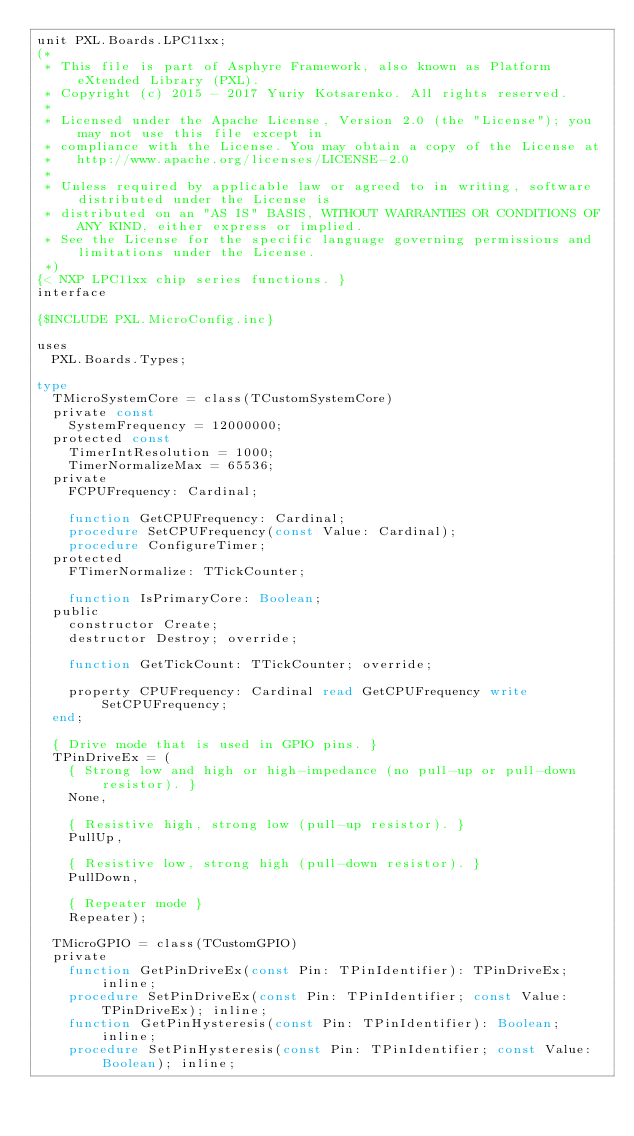<code> <loc_0><loc_0><loc_500><loc_500><_Pascal_>unit PXL.Boards.LPC11xx;
(*
 * This file is part of Asphyre Framework, also known as Platform eXtended Library (PXL).
 * Copyright (c) 2015 - 2017 Yuriy Kotsarenko. All rights reserved.
 *
 * Licensed under the Apache License, Version 2.0 (the "License"); you may not use this file except in
 * compliance with the License. You may obtain a copy of the License at
 *   http://www.apache.org/licenses/LICENSE-2.0
 *
 * Unless required by applicable law or agreed to in writing, software distributed under the License is
 * distributed on an "AS IS" BASIS, WITHOUT WARRANTIES OR CONDITIONS OF ANY KIND, either express or implied.
 * See the License for the specific language governing permissions and limitations under the License.
 *)
{< NXP LPC11xx chip series functions. }
interface

{$INCLUDE PXL.MicroConfig.inc}

uses
  PXL.Boards.Types;

type
  TMicroSystemCore = class(TCustomSystemCore)
  private const
    SystemFrequency = 12000000;
  protected const
    TimerIntResolution = 1000;
    TimerNormalizeMax = 65536;
  private
    FCPUFrequency: Cardinal;

    function GetCPUFrequency: Cardinal;
    procedure SetCPUFrequency(const Value: Cardinal);
    procedure ConfigureTimer;
  protected
    FTimerNormalize: TTickCounter;

    function IsPrimaryCore: Boolean;
  public
    constructor Create;
    destructor Destroy; override;

    function GetTickCount: TTickCounter; override;

    property CPUFrequency: Cardinal read GetCPUFrequency write SetCPUFrequency;
  end;

  { Drive mode that is used in GPIO pins. }
  TPinDriveEx = (
    { Strong low and high or high-impedance (no pull-up or pull-down resistor). }
    None,

    { Resistive high, strong low (pull-up resistor). }
    PullUp,

    { Resistive low, strong high (pull-down resistor). }
    PullDown,

    { Repeater mode }
    Repeater);

  TMicroGPIO = class(TCustomGPIO)
  private
    function GetPinDriveEx(const Pin: TPinIdentifier): TPinDriveEx; inline;
    procedure SetPinDriveEx(const Pin: TPinIdentifier; const Value: TPinDriveEx); inline;
    function GetPinHysteresis(const Pin: TPinIdentifier): Boolean; inline;
    procedure SetPinHysteresis(const Pin: TPinIdentifier; const Value: Boolean); inline;</code> 